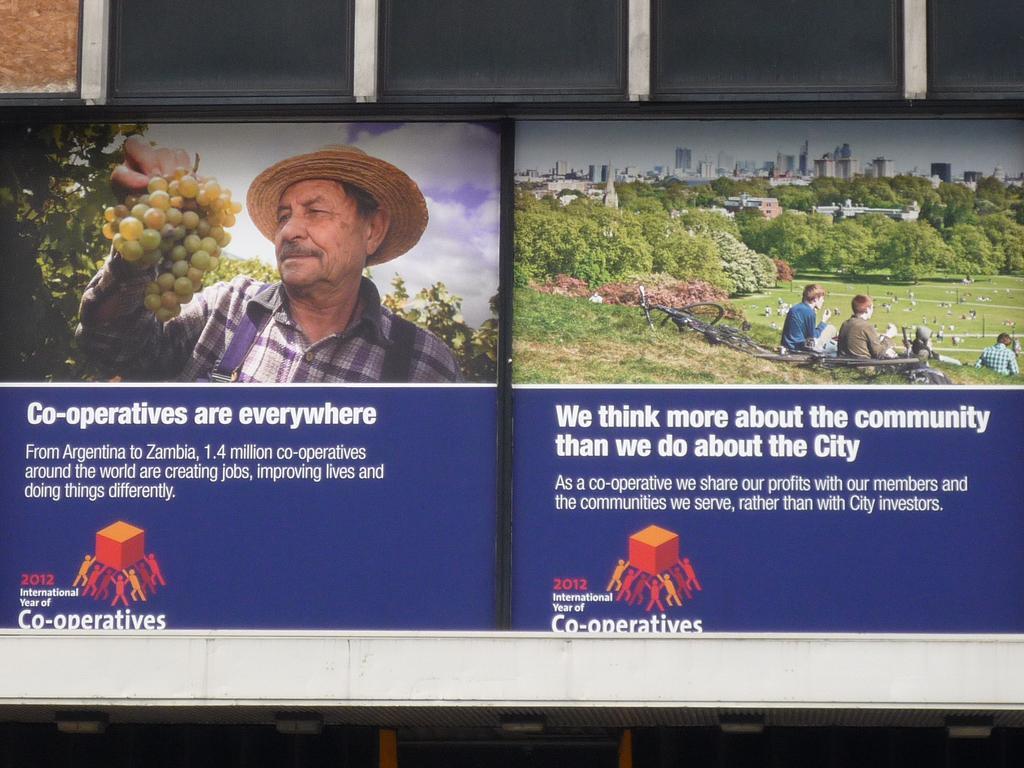How would you summarize this image in a sentence or two? In this image I can see a text, logo, a person is holding a bunch of grapes, vehicles, a crowd on grass, trees, buildings and the sky. This image looks like an edited photo. 